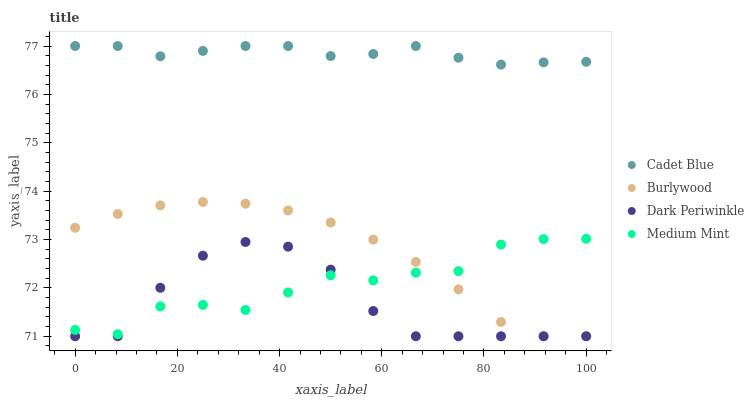Does Dark Periwinkle have the minimum area under the curve?
Answer yes or no. Yes. Does Cadet Blue have the maximum area under the curve?
Answer yes or no. Yes. Does Medium Mint have the minimum area under the curve?
Answer yes or no. No. Does Medium Mint have the maximum area under the curve?
Answer yes or no. No. Is Burlywood the smoothest?
Answer yes or no. Yes. Is Medium Mint the roughest?
Answer yes or no. Yes. Is Cadet Blue the smoothest?
Answer yes or no. No. Is Cadet Blue the roughest?
Answer yes or no. No. Does Burlywood have the lowest value?
Answer yes or no. Yes. Does Medium Mint have the lowest value?
Answer yes or no. No. Does Cadet Blue have the highest value?
Answer yes or no. Yes. Does Medium Mint have the highest value?
Answer yes or no. No. Is Dark Periwinkle less than Cadet Blue?
Answer yes or no. Yes. Is Cadet Blue greater than Burlywood?
Answer yes or no. Yes. Does Dark Periwinkle intersect Medium Mint?
Answer yes or no. Yes. Is Dark Periwinkle less than Medium Mint?
Answer yes or no. No. Is Dark Periwinkle greater than Medium Mint?
Answer yes or no. No. Does Dark Periwinkle intersect Cadet Blue?
Answer yes or no. No. 